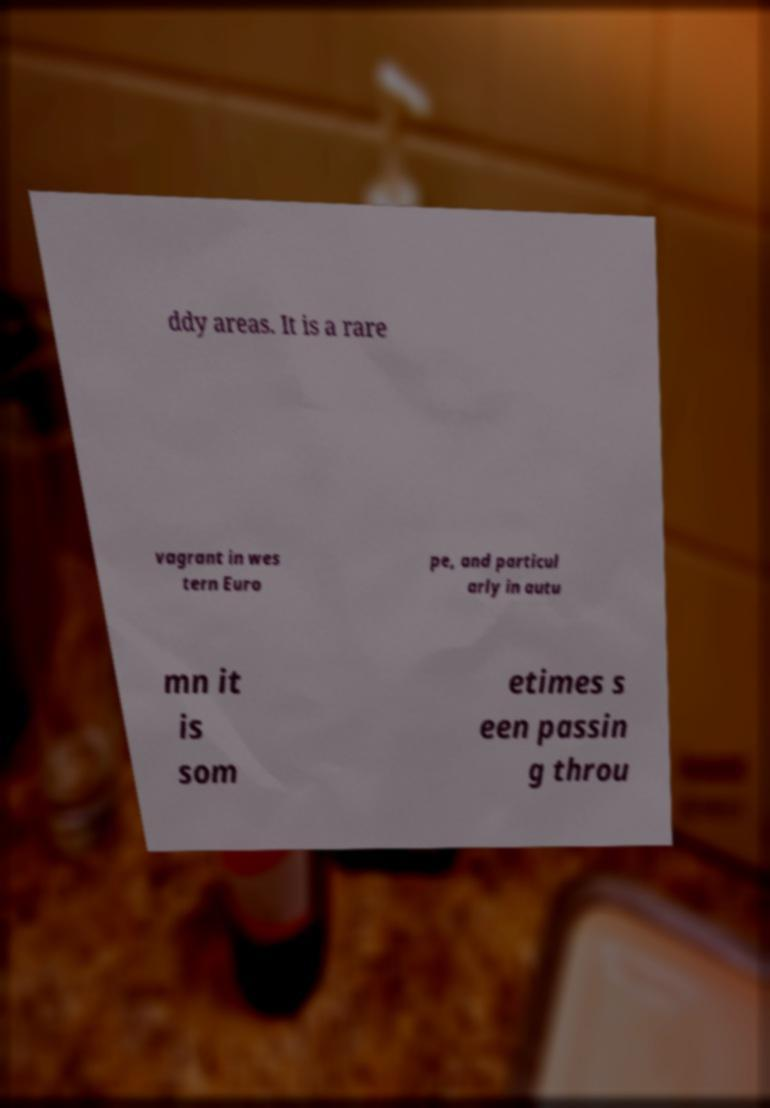Please read and relay the text visible in this image. What does it say? ddy areas. It is a rare vagrant in wes tern Euro pe, and particul arly in autu mn it is som etimes s een passin g throu 